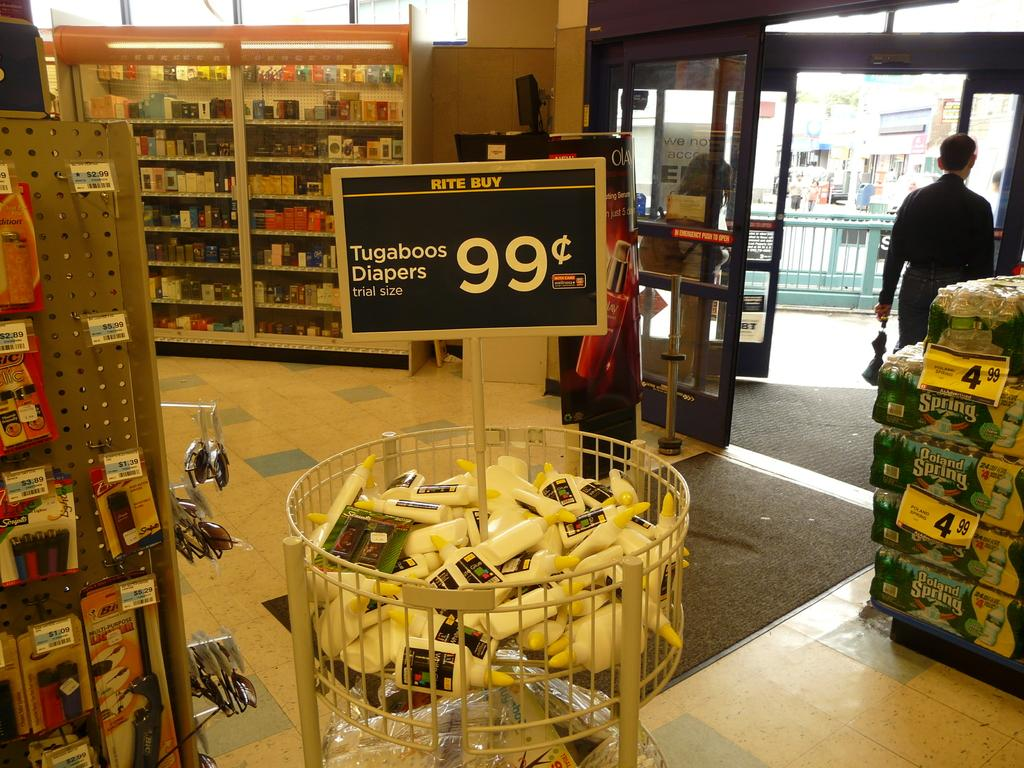<image>
Summarize the visual content of the image. Tugaboos Diapers are on sale for 99 cents at Rite Buy. 